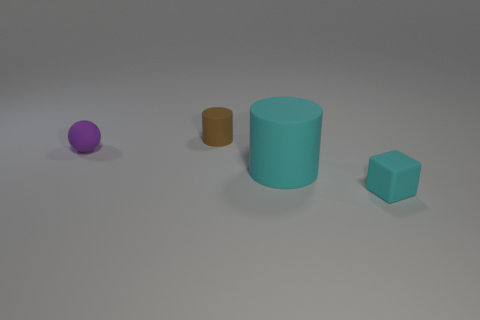Subtract all balls. How many objects are left? 3 Add 4 purple spheres. How many objects exist? 8 Subtract all cyan rubber balls. Subtract all tiny matte blocks. How many objects are left? 3 Add 2 small purple matte spheres. How many small purple matte spheres are left? 3 Add 1 matte blocks. How many matte blocks exist? 2 Subtract 0 gray cylinders. How many objects are left? 4 